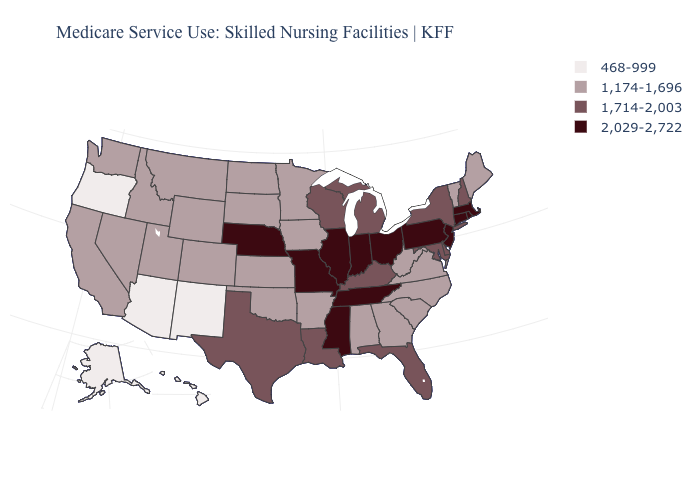What is the value of Colorado?
Keep it brief. 1,174-1,696. What is the value of Virginia?
Concise answer only. 1,174-1,696. Name the states that have a value in the range 1,714-2,003?
Be succinct. Delaware, Florida, Kentucky, Louisiana, Maryland, Michigan, New Hampshire, New York, Texas, Wisconsin. What is the value of Montana?
Give a very brief answer. 1,174-1,696. Does the map have missing data?
Concise answer only. No. What is the value of Connecticut?
Concise answer only. 2,029-2,722. Does the map have missing data?
Answer briefly. No. Among the states that border Idaho , does Utah have the highest value?
Give a very brief answer. Yes. Is the legend a continuous bar?
Quick response, please. No. What is the highest value in the USA?
Answer briefly. 2,029-2,722. Does the map have missing data?
Keep it brief. No. What is the value of Georgia?
Write a very short answer. 1,174-1,696. Name the states that have a value in the range 1,714-2,003?
Short answer required. Delaware, Florida, Kentucky, Louisiana, Maryland, Michigan, New Hampshire, New York, Texas, Wisconsin. What is the value of Pennsylvania?
Answer briefly. 2,029-2,722. Is the legend a continuous bar?
Be succinct. No. 